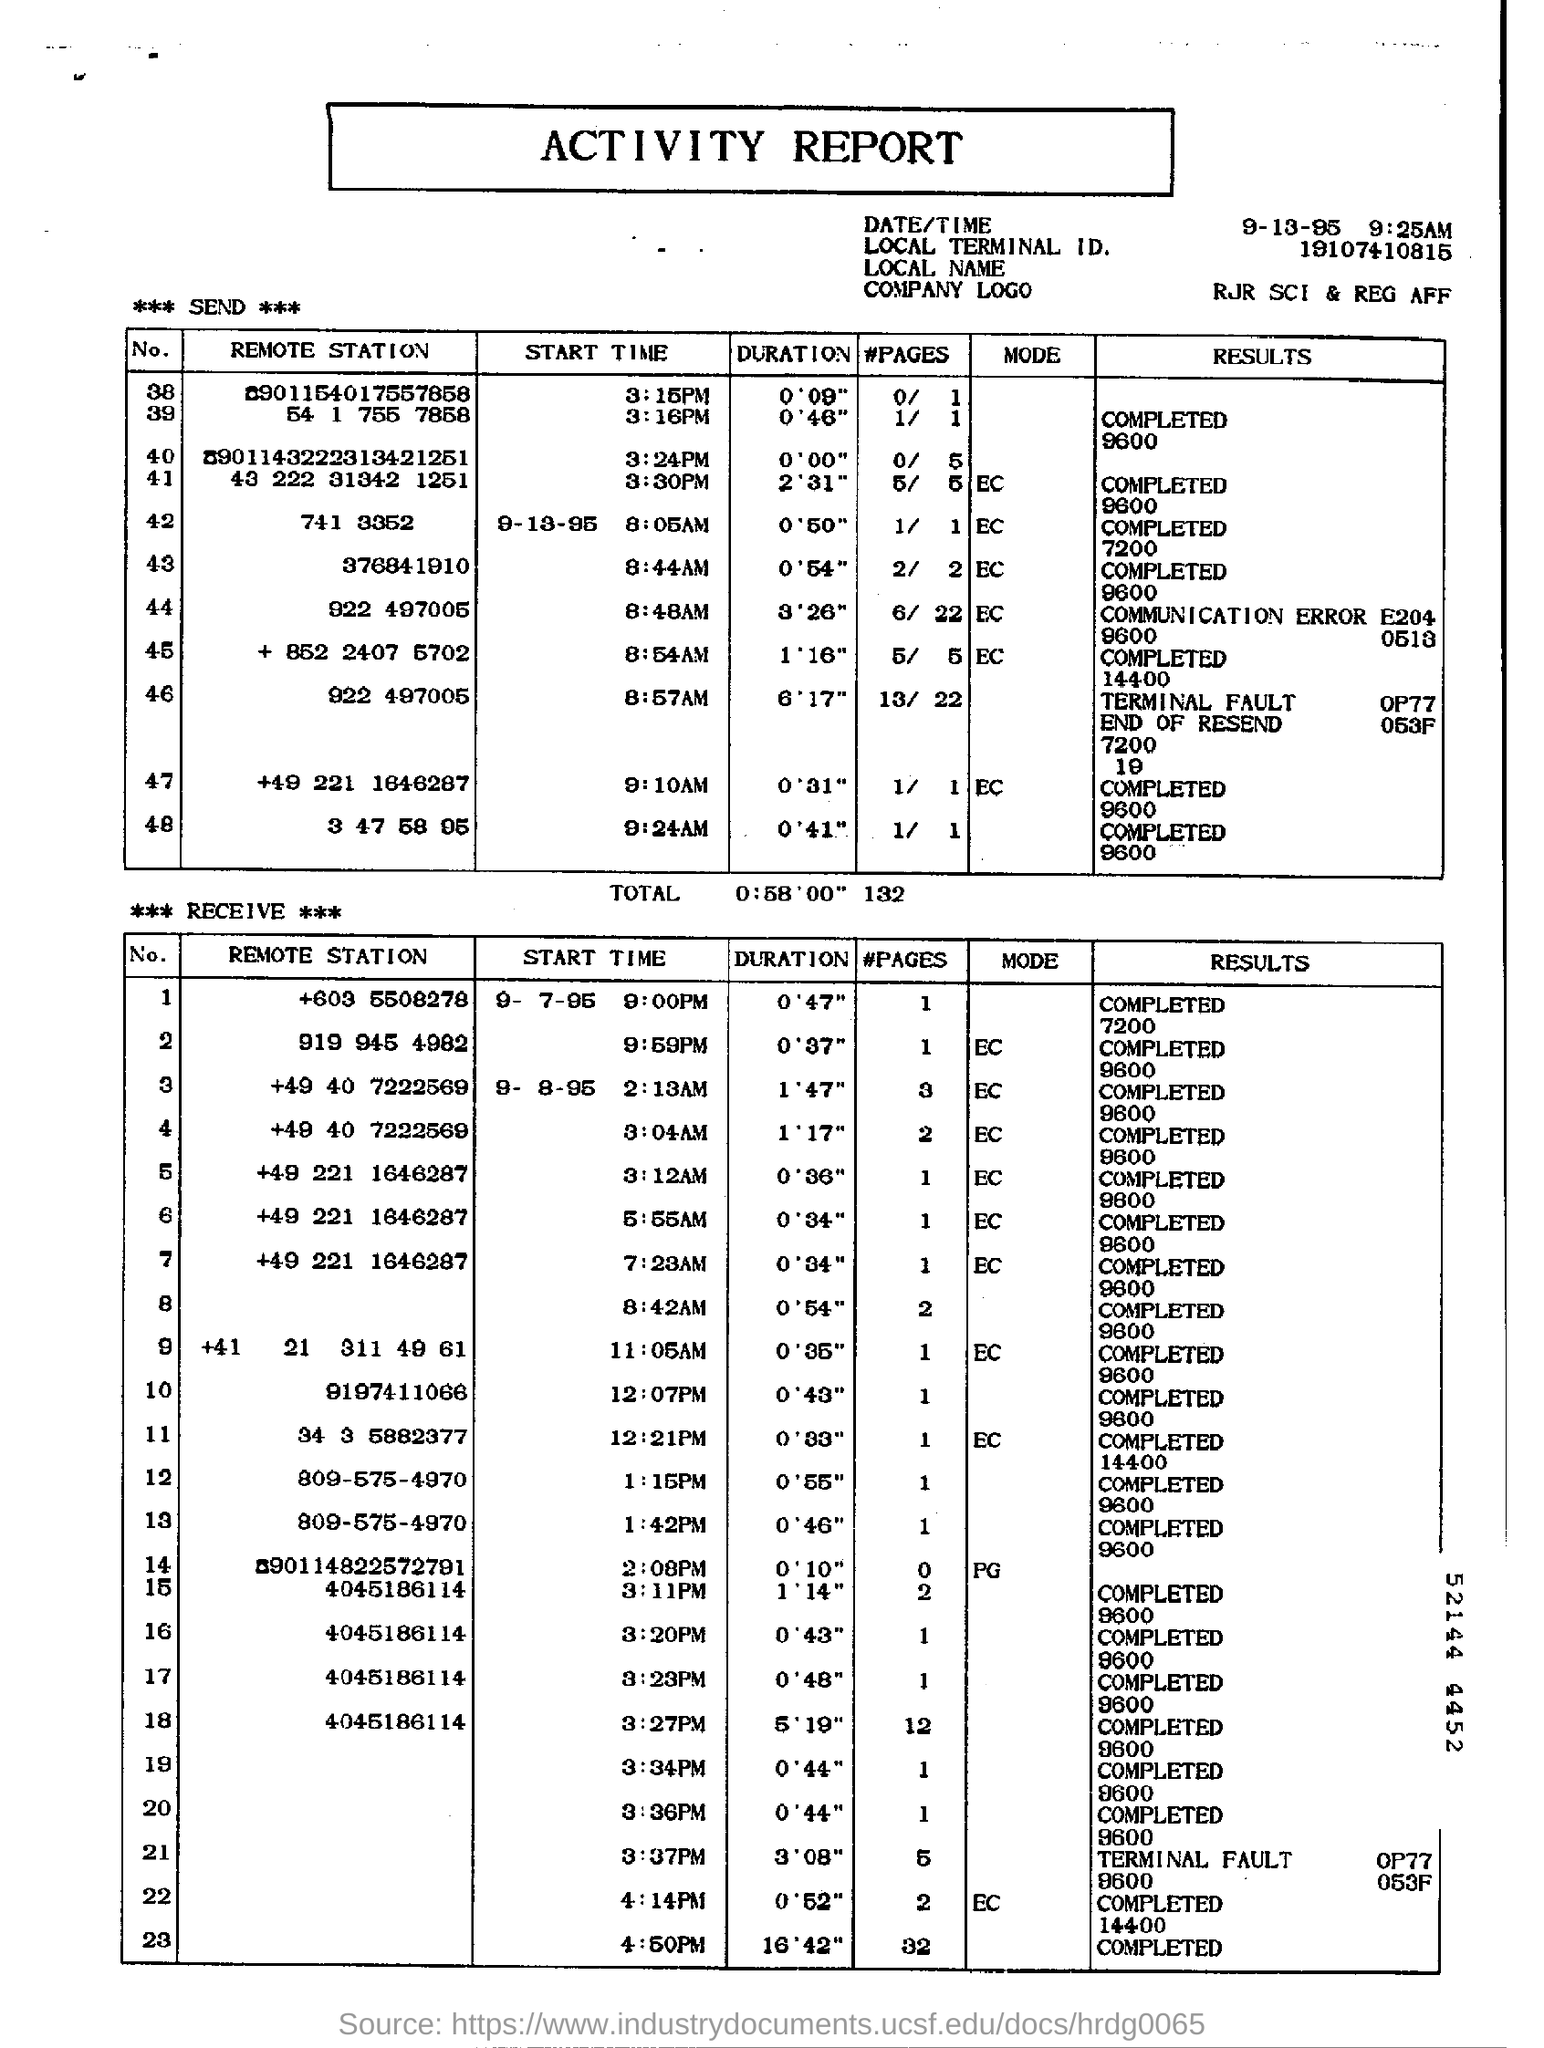What is the Local Terminal ID mentioned in the report?
Your response must be concise. 19107410815. 